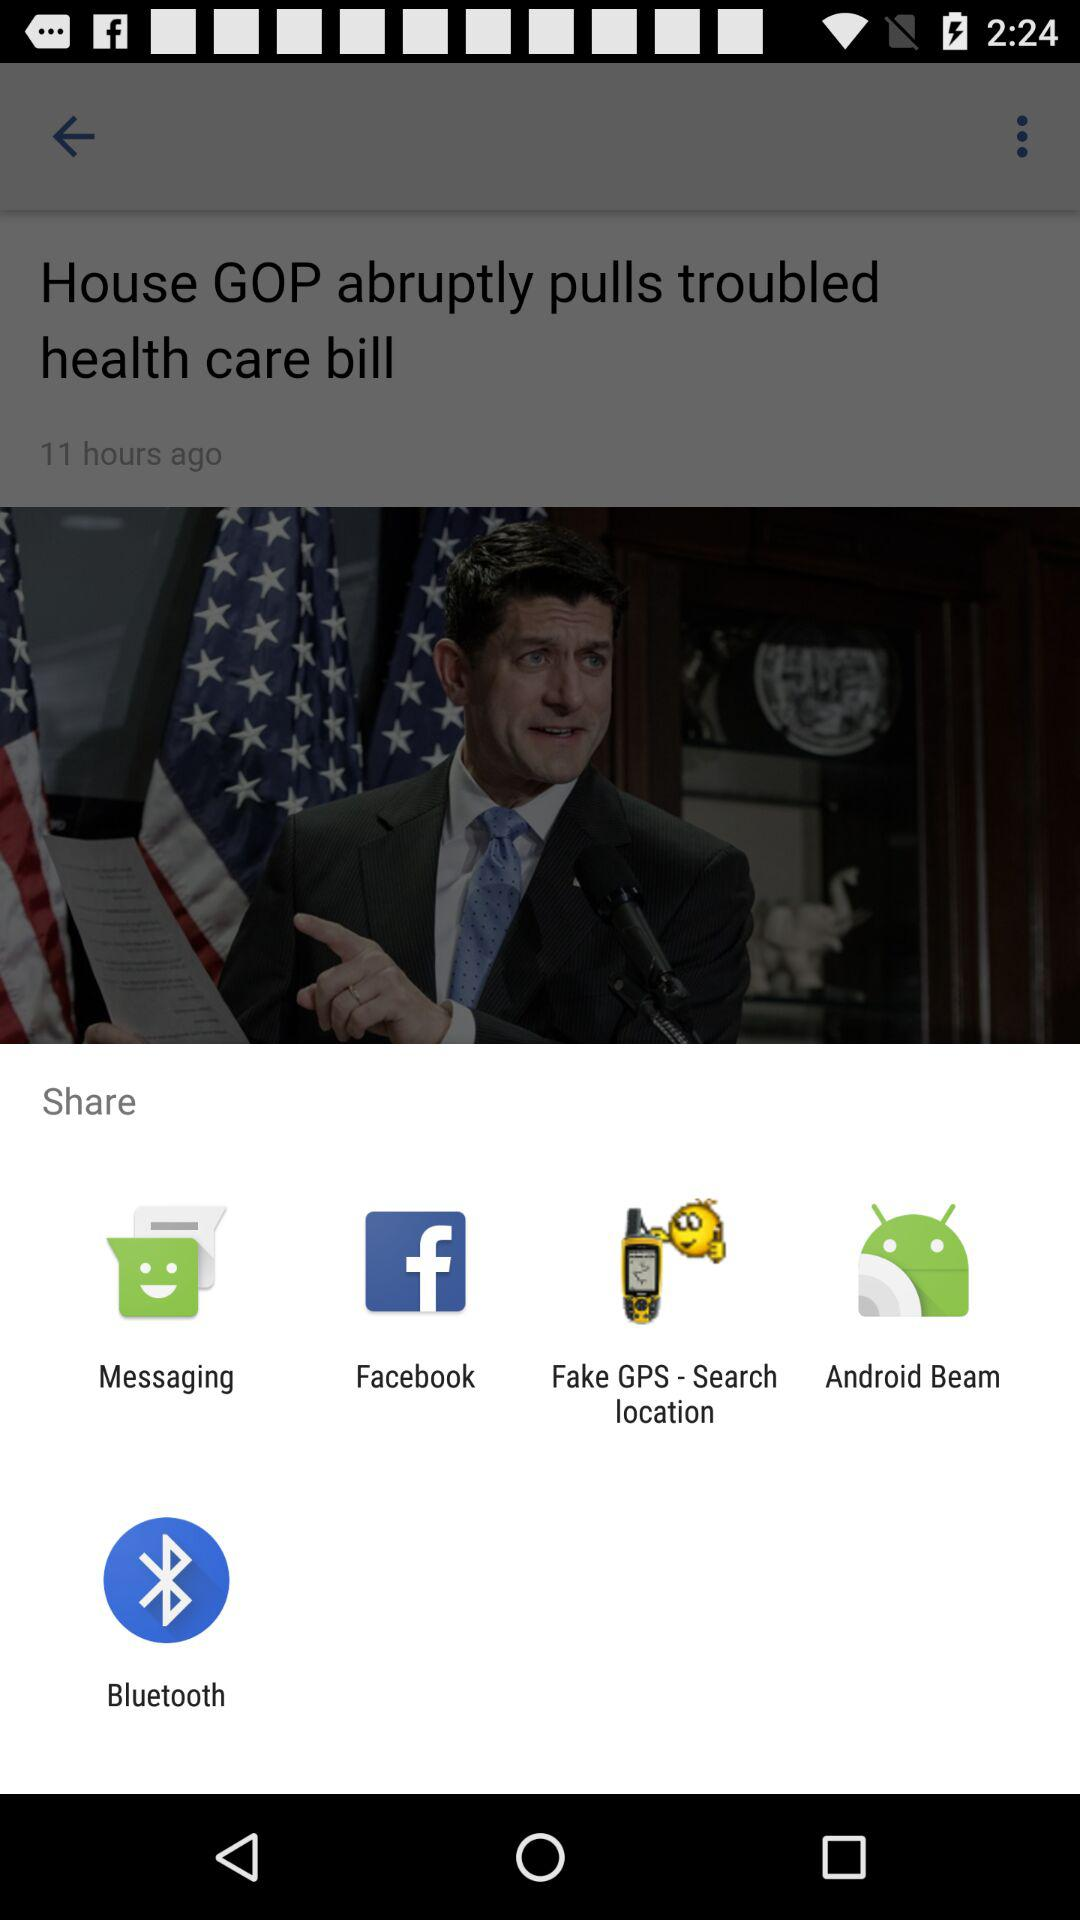Through which app can I share the content? You can share the content through "Messaging", "Facebook", "Fake GPS - Search location", "Android Beam" and "Bluetooth". 